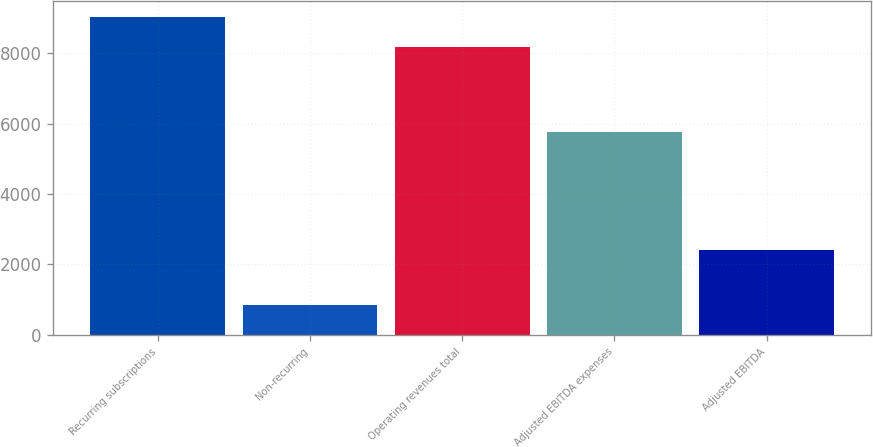Convert chart. <chart><loc_0><loc_0><loc_500><loc_500><bar_chart><fcel>Recurring subscriptions<fcel>Non-recurring<fcel>Operating revenues total<fcel>Adjusted EBITDA expenses<fcel>Adjusted EBITDA<nl><fcel>9024<fcel>845<fcel>8179<fcel>5759<fcel>2420<nl></chart> 